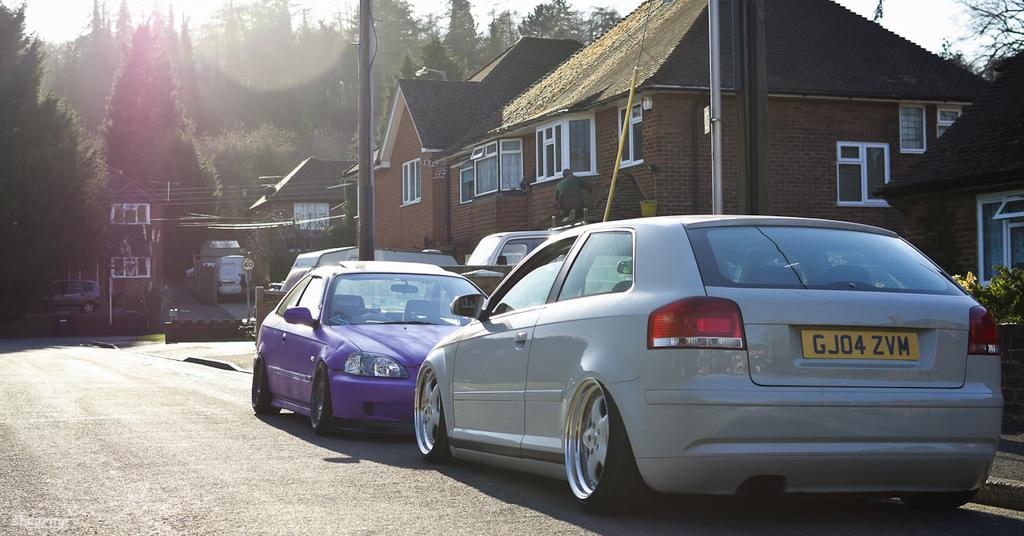What can be seen on the road in the image? There are vehicles on the road in the image. What type of structures are visible in the image? There are buildings with windows in the image. What objects are present along the road or in the vicinity of the buildings? There are poles in the image. What can be seen in the distance or background of the image? Trees and the sky are visible in the background of the image. Can you tell me how many tomatoes are growing on the poles in the image? There are no tomatoes present in the image; the poles are likely for streetlights or other purposes. What type of memory is being stored in the buildings in the image? There is no indication of any memory being stored in the buildings in the image; they are simply structures with windows. 